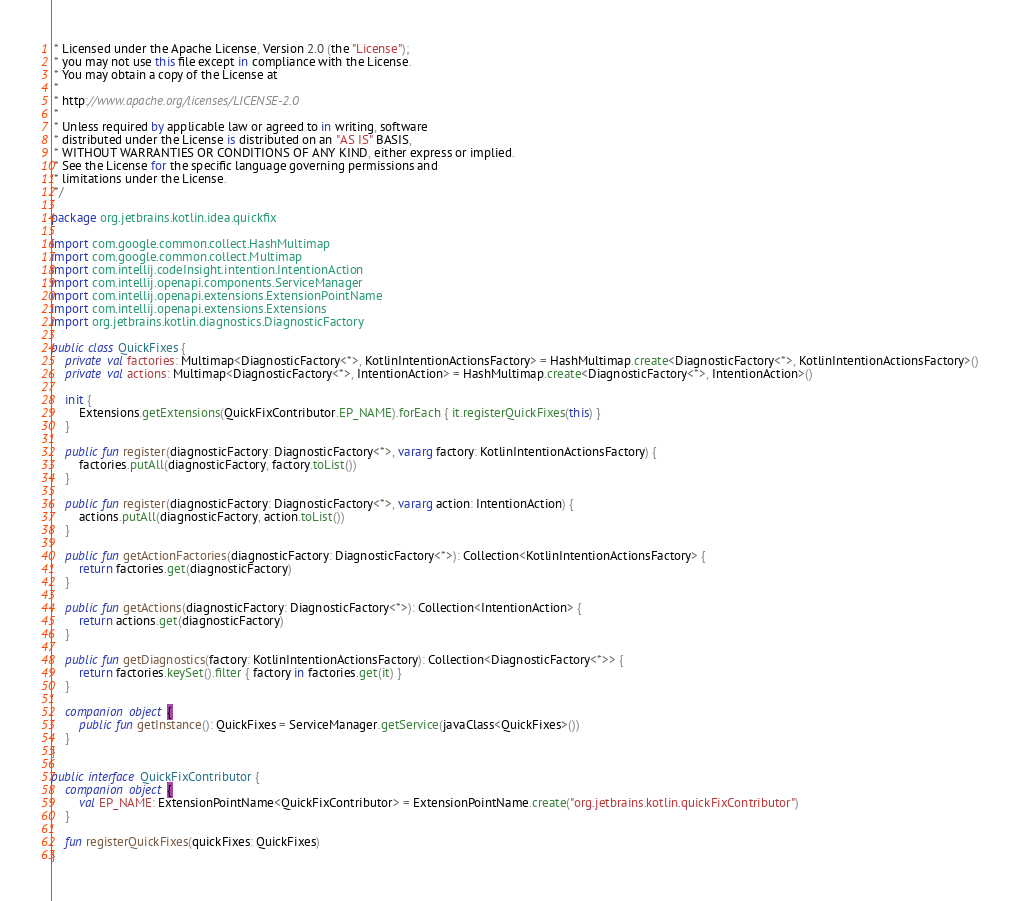Convert code to text. <code><loc_0><loc_0><loc_500><loc_500><_Kotlin_> * Licensed under the Apache License, Version 2.0 (the "License");
 * you may not use this file except in compliance with the License.
 * You may obtain a copy of the License at
 *
 * http://www.apache.org/licenses/LICENSE-2.0
 *
 * Unless required by applicable law or agreed to in writing, software
 * distributed under the License is distributed on an "AS IS" BASIS,
 * WITHOUT WARRANTIES OR CONDITIONS OF ANY KIND, either express or implied.
 * See the License for the specific language governing permissions and
 * limitations under the License.
 */

package org.jetbrains.kotlin.idea.quickfix

import com.google.common.collect.HashMultimap
import com.google.common.collect.Multimap
import com.intellij.codeInsight.intention.IntentionAction
import com.intellij.openapi.components.ServiceManager
import com.intellij.openapi.extensions.ExtensionPointName
import com.intellij.openapi.extensions.Extensions
import org.jetbrains.kotlin.diagnostics.DiagnosticFactory

public class QuickFixes {
    private val factories: Multimap<DiagnosticFactory<*>, KotlinIntentionActionsFactory> = HashMultimap.create<DiagnosticFactory<*>, KotlinIntentionActionsFactory>()
    private val actions: Multimap<DiagnosticFactory<*>, IntentionAction> = HashMultimap.create<DiagnosticFactory<*>, IntentionAction>()

    init {
        Extensions.getExtensions(QuickFixContributor.EP_NAME).forEach { it.registerQuickFixes(this) }
    }

    public fun register(diagnosticFactory: DiagnosticFactory<*>, vararg factory: KotlinIntentionActionsFactory) {
        factories.putAll(diagnosticFactory, factory.toList())
    }

    public fun register(diagnosticFactory: DiagnosticFactory<*>, vararg action: IntentionAction) {
        actions.putAll(diagnosticFactory, action.toList())
    }

    public fun getActionFactories(diagnosticFactory: DiagnosticFactory<*>): Collection<KotlinIntentionActionsFactory> {
        return factories.get(diagnosticFactory)
    }

    public fun getActions(diagnosticFactory: DiagnosticFactory<*>): Collection<IntentionAction> {
        return actions.get(diagnosticFactory)
    }

    public fun getDiagnostics(factory: KotlinIntentionActionsFactory): Collection<DiagnosticFactory<*>> {
        return factories.keySet().filter { factory in factories.get(it) }
    }

    companion object {
        public fun getInstance(): QuickFixes = ServiceManager.getService(javaClass<QuickFixes>())
    }
}

public interface QuickFixContributor {
    companion object {
        val EP_NAME: ExtensionPointName<QuickFixContributor> = ExtensionPointName.create("org.jetbrains.kotlin.quickFixContributor")
    }

    fun registerQuickFixes(quickFixes: QuickFixes)
}</code> 